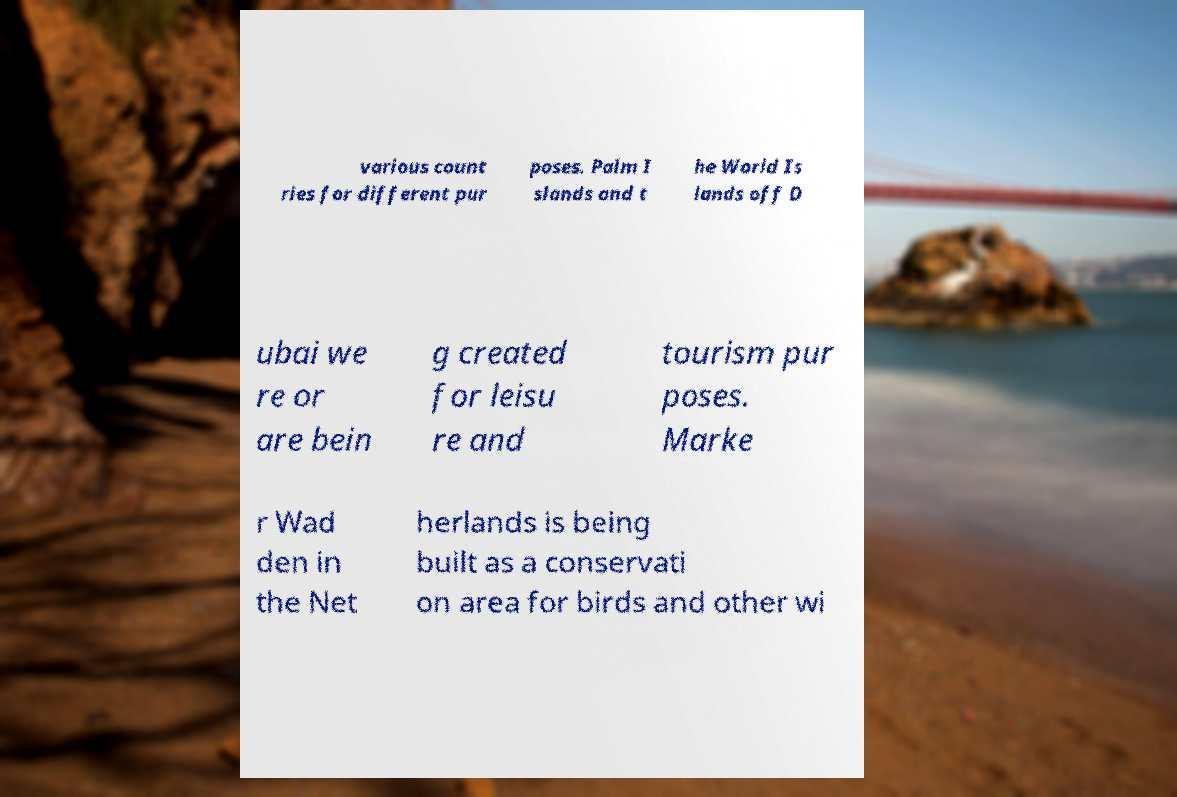Could you extract and type out the text from this image? various count ries for different pur poses. Palm I slands and t he World Is lands off D ubai we re or are bein g created for leisu re and tourism pur poses. Marke r Wad den in the Net herlands is being built as a conservati on area for birds and other wi 